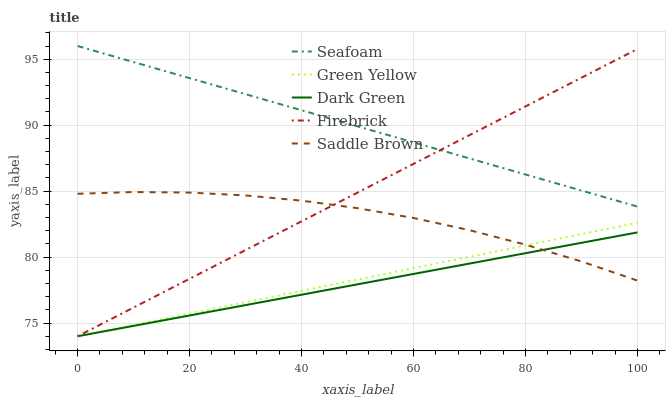Does Dark Green have the minimum area under the curve?
Answer yes or no. Yes. Does Seafoam have the maximum area under the curve?
Answer yes or no. Yes. Does Firebrick have the minimum area under the curve?
Answer yes or no. No. Does Firebrick have the maximum area under the curve?
Answer yes or no. No. Is Seafoam the smoothest?
Answer yes or no. Yes. Is Saddle Brown the roughest?
Answer yes or no. Yes. Is Firebrick the smoothest?
Answer yes or no. No. Is Firebrick the roughest?
Answer yes or no. No. Does Firebrick have the lowest value?
Answer yes or no. Yes. Does Seafoam have the lowest value?
Answer yes or no. No. Does Seafoam have the highest value?
Answer yes or no. Yes. Does Firebrick have the highest value?
Answer yes or no. No. Is Saddle Brown less than Seafoam?
Answer yes or no. Yes. Is Seafoam greater than Dark Green?
Answer yes or no. Yes. Does Firebrick intersect Green Yellow?
Answer yes or no. Yes. Is Firebrick less than Green Yellow?
Answer yes or no. No. Is Firebrick greater than Green Yellow?
Answer yes or no. No. Does Saddle Brown intersect Seafoam?
Answer yes or no. No. 